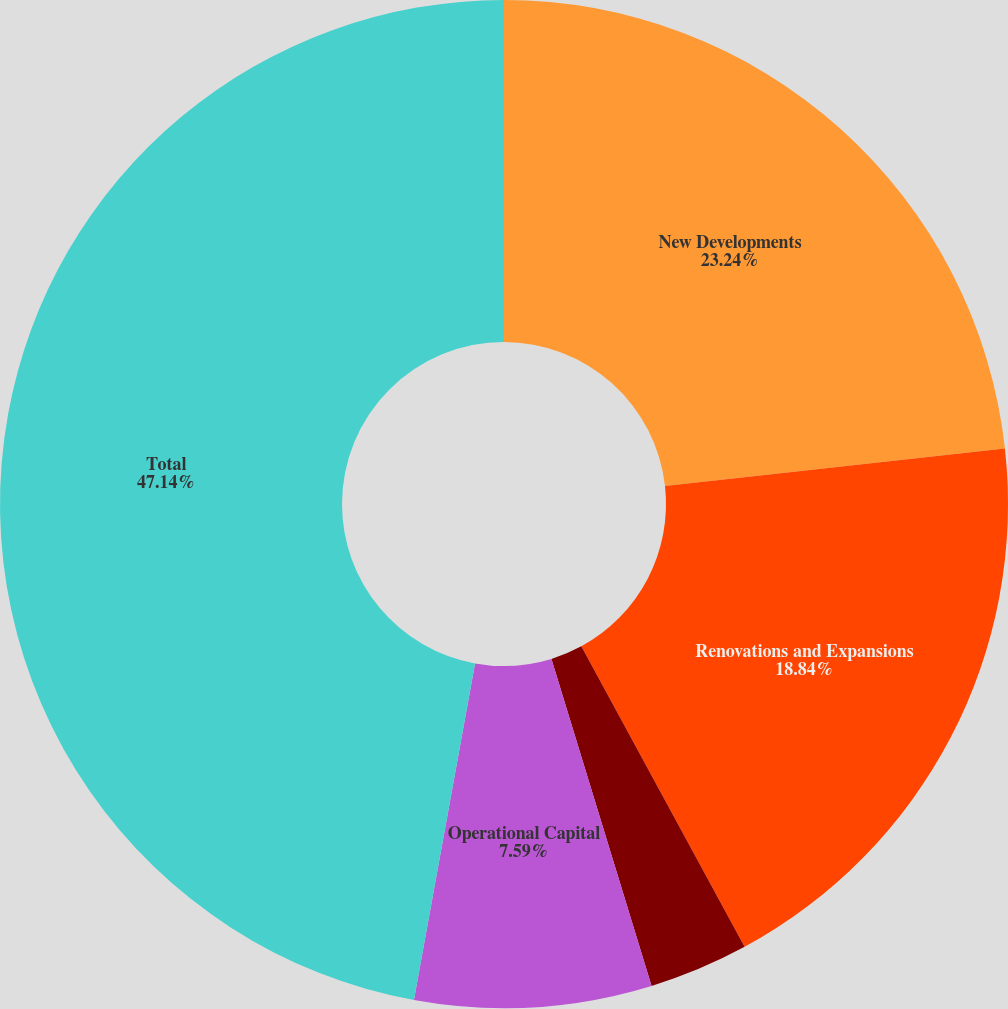Convert chart. <chart><loc_0><loc_0><loc_500><loc_500><pie_chart><fcel>New Developments<fcel>Renovations and Expansions<fcel>Tenant Allowances<fcel>Operational Capital<fcel>Total<nl><fcel>23.24%<fcel>18.84%<fcel>3.19%<fcel>7.59%<fcel>47.14%<nl></chart> 